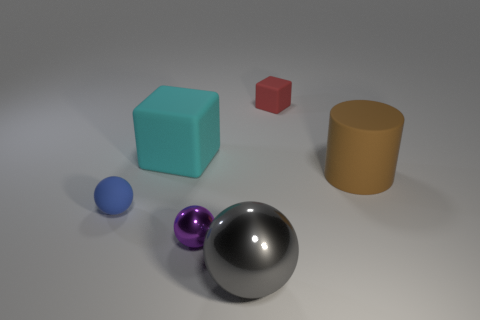Subtract all tiny purple shiny balls. How many balls are left? 2 Add 3 cyan objects. How many objects exist? 9 Subtract all blocks. How many objects are left? 4 Subtract 2 cubes. How many cubes are left? 0 Subtract all purple rubber objects. Subtract all large brown objects. How many objects are left? 5 Add 4 gray metal objects. How many gray metal objects are left? 5 Add 3 big rubber cubes. How many big rubber cubes exist? 4 Subtract all purple spheres. How many spheres are left? 2 Subtract 0 green blocks. How many objects are left? 6 Subtract all yellow cubes. Subtract all gray balls. How many cubes are left? 2 